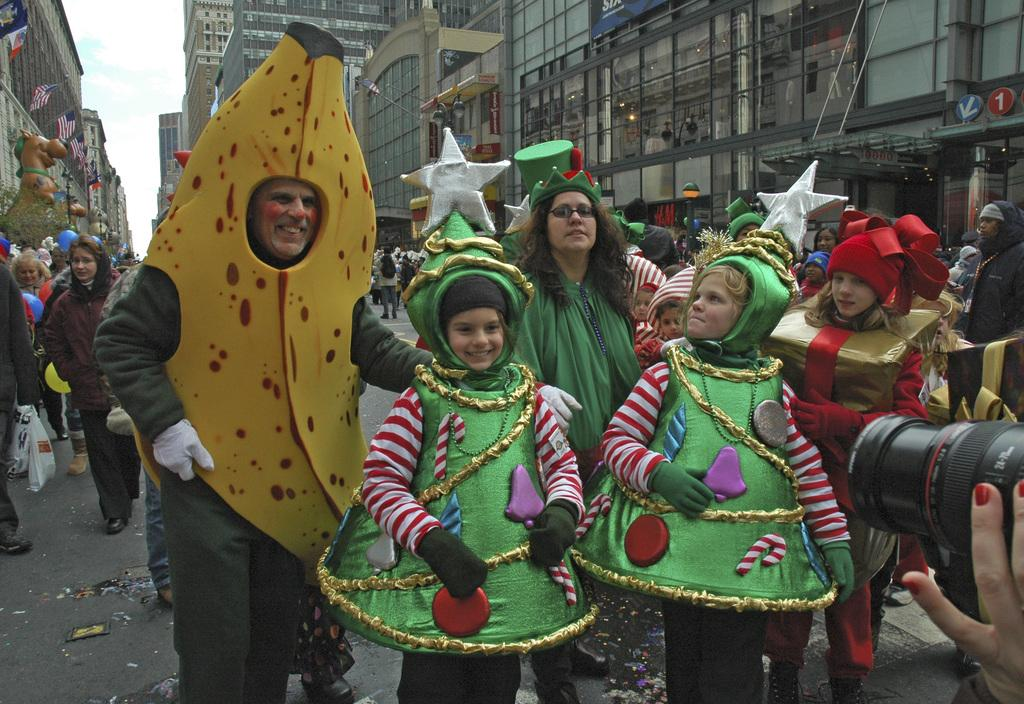What is happening on the road in the image? There are people on the road in the image. What can be seen in the distance behind the people? There are buildings and flags in the background of the image. What is visible in the sky in the image? The sky is visible in the background of the image. Are there any cracks visible on the road in the image? There is no mention of cracks on the road in the provided facts, so we cannot determine if any are visible in the image. 